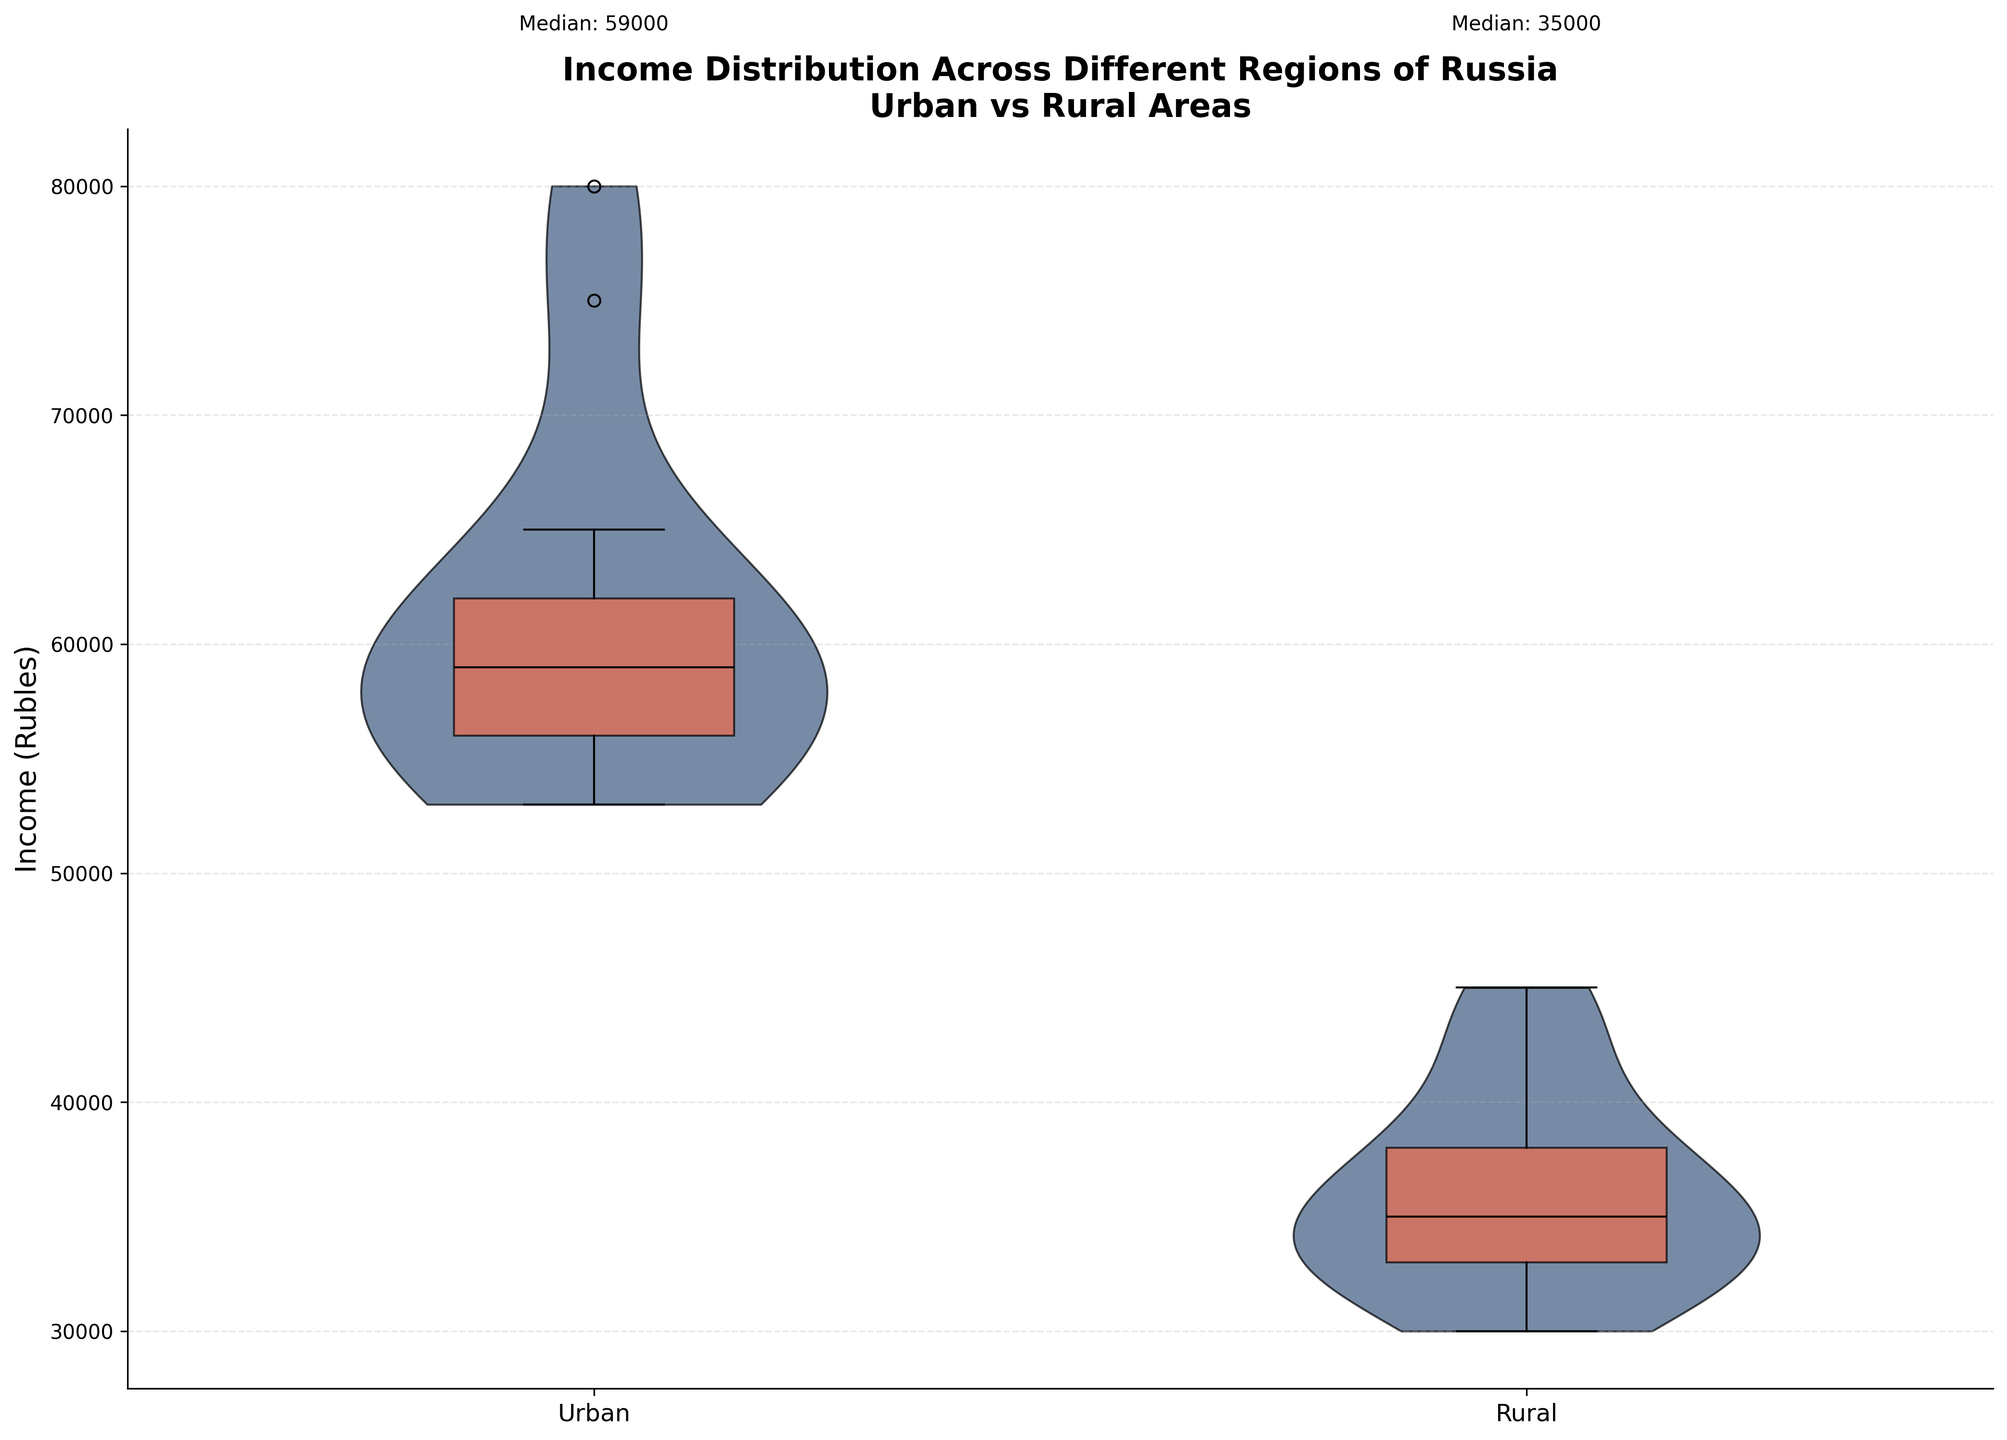What's the title of the figure? The title is usually placed at the top of the figure. Here, it reads "Income Distribution Across Different Regions of Russia\nUrban vs Rural Areas".
Answer: Income Distribution Across Different Regions of Russia\nUrban vs Rural Areas What are the categories compared on the x-axis? The x-axis compares two categories, which are labeled as "Urban" and "Rural".
Answer: Urban and Rural Which area has a higher median income, Urban or Rural? The text annotations at the top of each category indicate the median income. The Urban category shows a median of 60000, while the Rural category shows a median of 37000. Thus, Urban has a higher median income.
Answer: Urban What color represents the violin plots in the figure? The violin plots are represented by a shade close to navy blue, as seen in the bodies of the violins.
Answer: Navy blue How do the Urban and Rural income distributions compare visually? Visually comparing the shapes, widths, and peaks of the violins, the Urban income distribution appears wider and has higher and more varied distributions than Rural. The Rural distribution is more compact.
Answer: Urban is wider and more varied, Rural is more compact What is the y-axis label in the figure? The y-axis label provides the unit of measurement for the data, and it states "Income (Rubles)".
Answer: Income (Rubles) Comparing the Urban and Rural areas, which distribution has more variability? By observing the width and spread of the violins and the box plots inside them, the Urban area has more variability, indicated by the broader spread of the Urban violin plot compared to the Rural one.
Answer: Urban How does the visualization show the median income values? The median income values are shown as black text annotations just above the top of each violin plot.
Answer: Through text annotations above each plot On average, how much higher is the median income in Urban areas compared to Rural areas? The Urban areas have a median income of 60000, whereas Rural areas have 37000. The difference is 60000 - 37000 = 23000.
Answer: 23000 Describe the overall pattern in income distribution between Urban and Rural areas across different regions in Russia. The overall pattern shows that Urban areas consistently have higher income distributions with more variation, while Rural areas have lower and more compact distributions. This indicates a significant income disparity between urban and rural settings.
Answer: Urban areas have higher and more varied income distributions; Rural areas are lower and more compact 